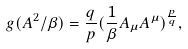Convert formula to latex. <formula><loc_0><loc_0><loc_500><loc_500>g ( A ^ { 2 } / \beta ) = \frac { q } { p } ( \frac { 1 } { \beta } A _ { \mu } A ^ { \mu } ) ^ { \frac { p } { q } } ,</formula> 